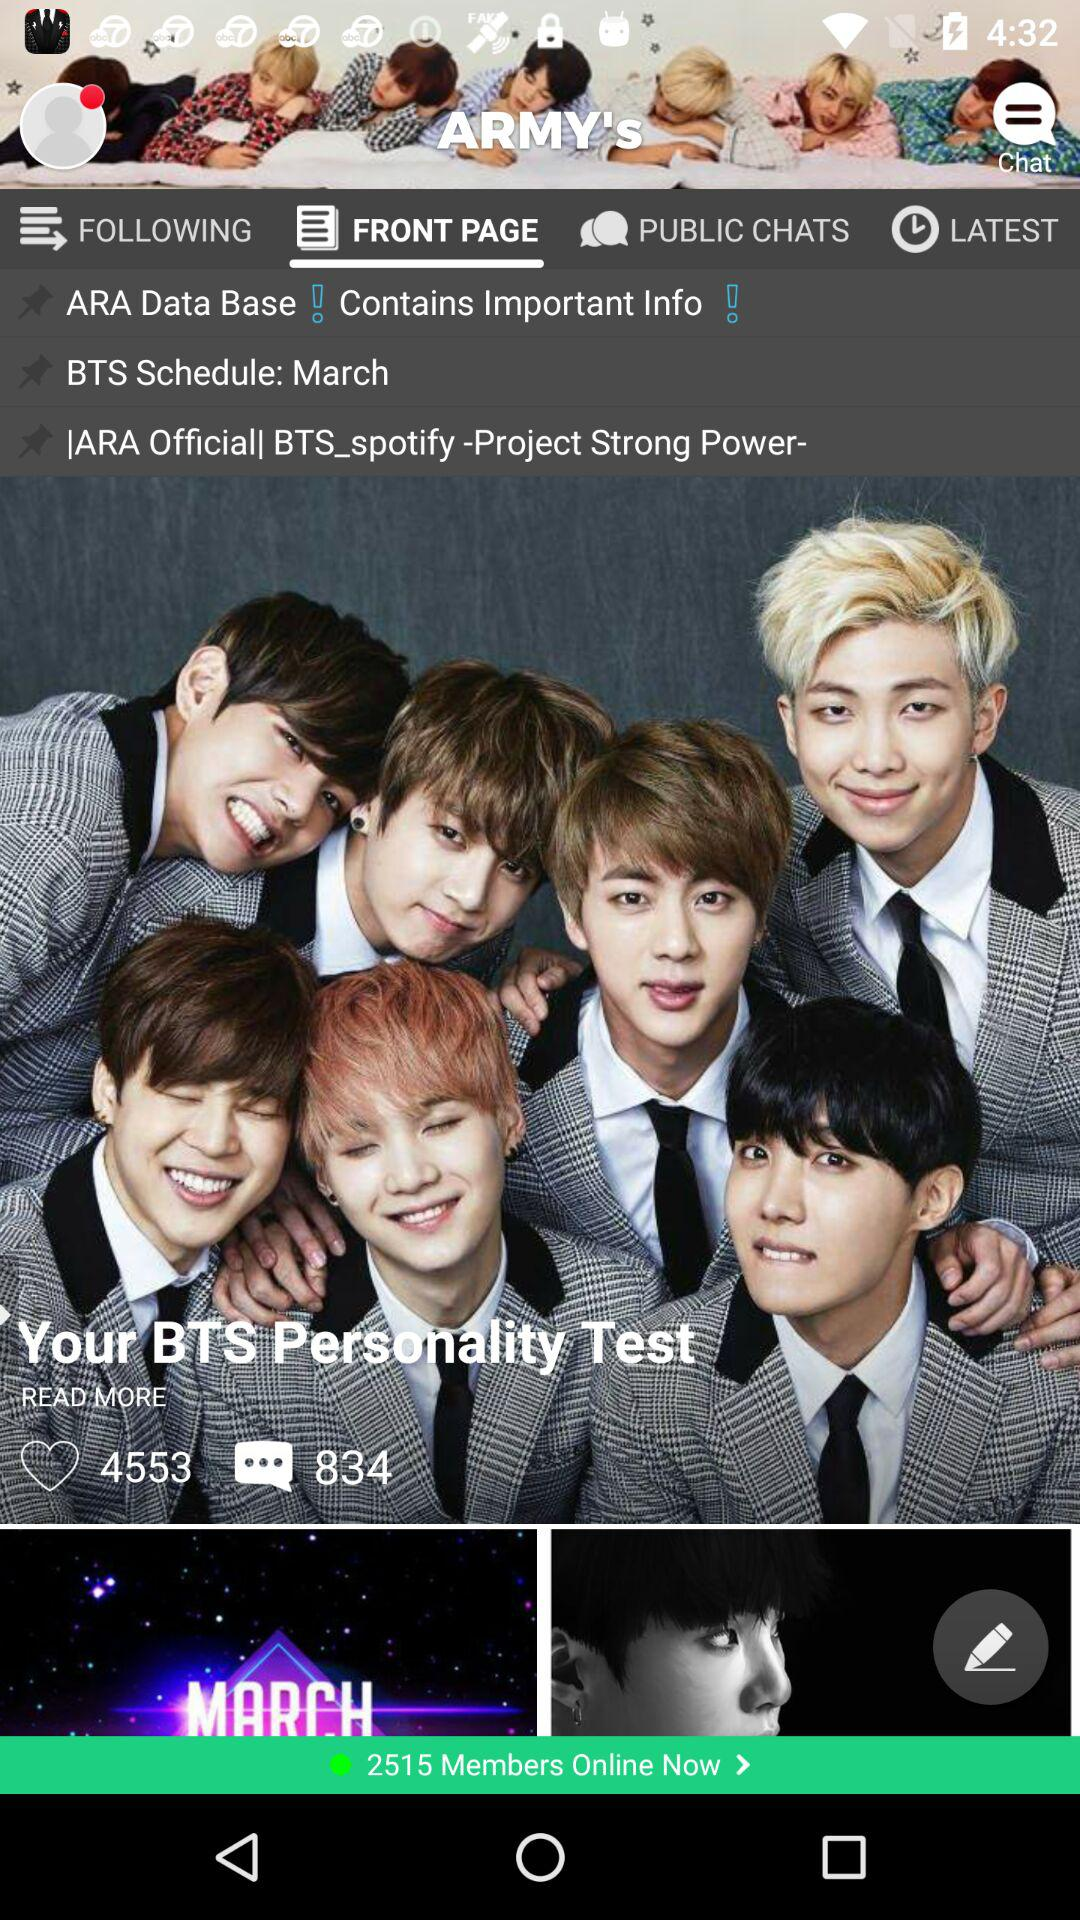How many comments are there? There are 834 comments. 